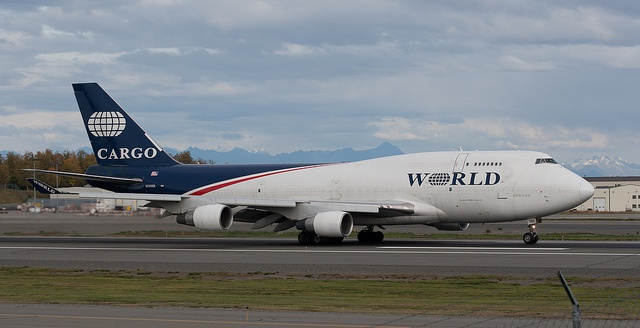Describe the objects in this image and their specific colors. I can see a airplane in gray, darkgray, black, and lightgray tones in this image. 